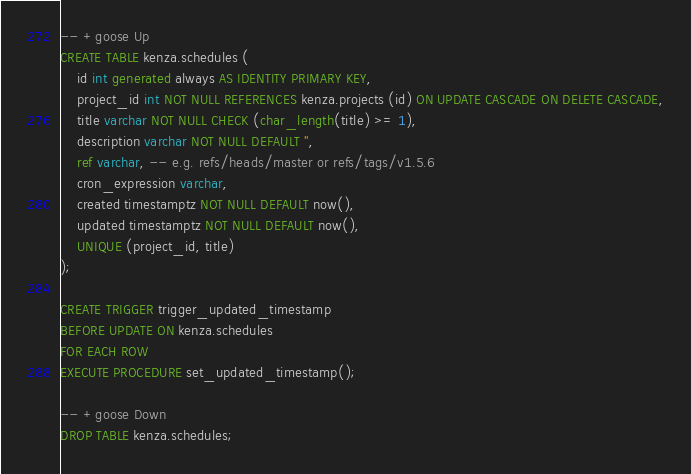Convert code to text. <code><loc_0><loc_0><loc_500><loc_500><_SQL_>-- +goose Up
CREATE TABLE kenza.schedules (
    id int generated always AS IDENTITY PRIMARY KEY, 
    project_id int NOT NULL REFERENCES kenza.projects (id) ON UPDATE CASCADE ON DELETE CASCADE,
    title varchar NOT NULL CHECK (char_length(title) >= 1),
    description varchar NOT NULL DEFAULT '',
    ref varchar, -- e.g. refs/heads/master or refs/tags/v1.5.6
    cron_expression varchar,
    created timestamptz NOT NULL DEFAULT now(),
    updated timestamptz NOT NULL DEFAULT now(),
    UNIQUE (project_id, title)
);

CREATE TRIGGER trigger_updated_timestamp
BEFORE UPDATE ON kenza.schedules
FOR EACH ROW
EXECUTE PROCEDURE set_updated_timestamp();

-- +goose Down
DROP TABLE kenza.schedules;</code> 